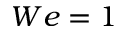Convert formula to latex. <formula><loc_0><loc_0><loc_500><loc_500>W e = 1</formula> 